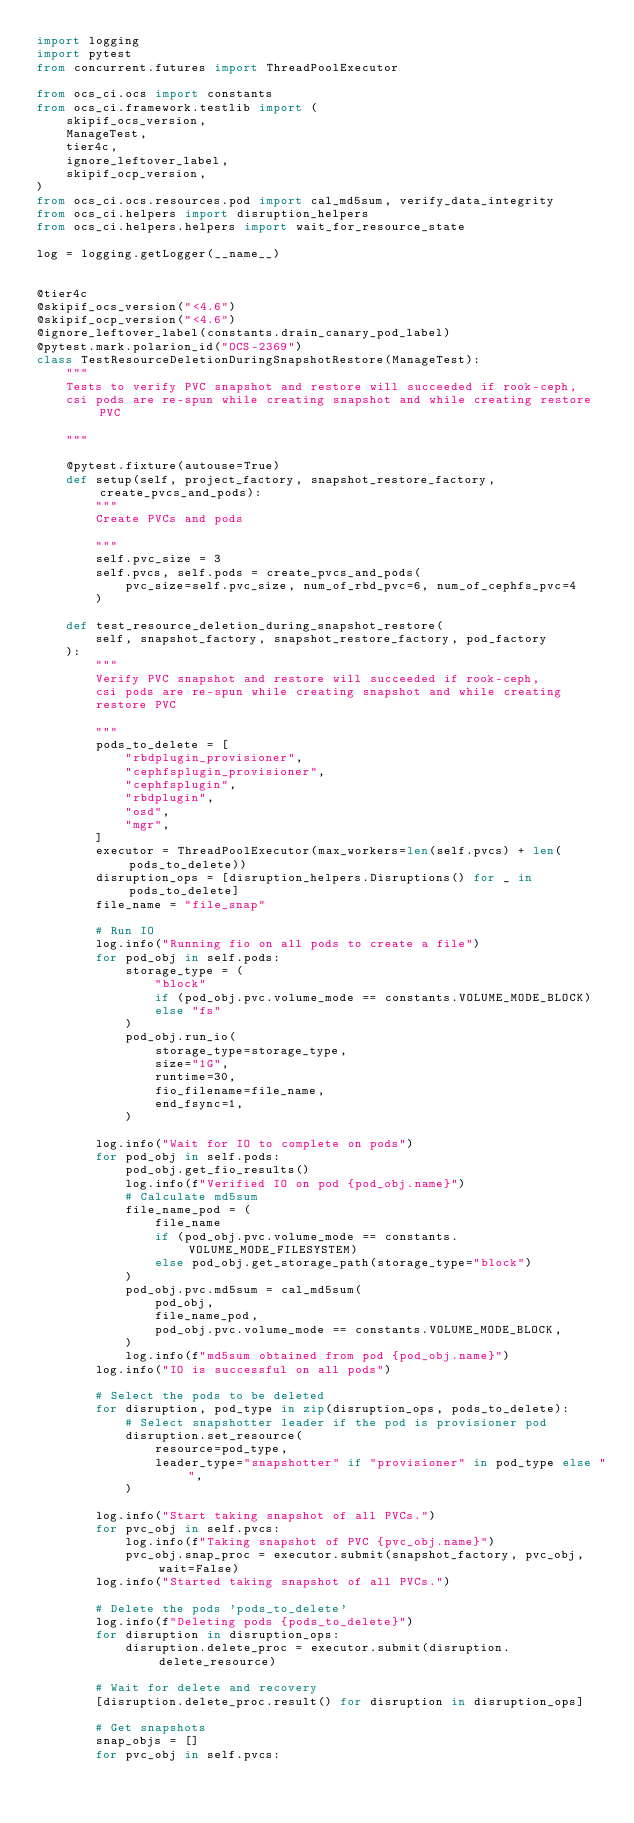Convert code to text. <code><loc_0><loc_0><loc_500><loc_500><_Python_>import logging
import pytest
from concurrent.futures import ThreadPoolExecutor

from ocs_ci.ocs import constants
from ocs_ci.framework.testlib import (
    skipif_ocs_version,
    ManageTest,
    tier4c,
    ignore_leftover_label,
    skipif_ocp_version,
)
from ocs_ci.ocs.resources.pod import cal_md5sum, verify_data_integrity
from ocs_ci.helpers import disruption_helpers
from ocs_ci.helpers.helpers import wait_for_resource_state

log = logging.getLogger(__name__)


@tier4c
@skipif_ocs_version("<4.6")
@skipif_ocp_version("<4.6")
@ignore_leftover_label(constants.drain_canary_pod_label)
@pytest.mark.polarion_id("OCS-2369")
class TestResourceDeletionDuringSnapshotRestore(ManageTest):
    """
    Tests to verify PVC snapshot and restore will succeeded if rook-ceph,
    csi pods are re-spun while creating snapshot and while creating restore PVC

    """

    @pytest.fixture(autouse=True)
    def setup(self, project_factory, snapshot_restore_factory, create_pvcs_and_pods):
        """
        Create PVCs and pods

        """
        self.pvc_size = 3
        self.pvcs, self.pods = create_pvcs_and_pods(
            pvc_size=self.pvc_size, num_of_rbd_pvc=6, num_of_cephfs_pvc=4
        )

    def test_resource_deletion_during_snapshot_restore(
        self, snapshot_factory, snapshot_restore_factory, pod_factory
    ):
        """
        Verify PVC snapshot and restore will succeeded if rook-ceph,
        csi pods are re-spun while creating snapshot and while creating
        restore PVC

        """
        pods_to_delete = [
            "rbdplugin_provisioner",
            "cephfsplugin_provisioner",
            "cephfsplugin",
            "rbdplugin",
            "osd",
            "mgr",
        ]
        executor = ThreadPoolExecutor(max_workers=len(self.pvcs) + len(pods_to_delete))
        disruption_ops = [disruption_helpers.Disruptions() for _ in pods_to_delete]
        file_name = "file_snap"

        # Run IO
        log.info("Running fio on all pods to create a file")
        for pod_obj in self.pods:
            storage_type = (
                "block"
                if (pod_obj.pvc.volume_mode == constants.VOLUME_MODE_BLOCK)
                else "fs"
            )
            pod_obj.run_io(
                storage_type=storage_type,
                size="1G",
                runtime=30,
                fio_filename=file_name,
                end_fsync=1,
            )

        log.info("Wait for IO to complete on pods")
        for pod_obj in self.pods:
            pod_obj.get_fio_results()
            log.info(f"Verified IO on pod {pod_obj.name}")
            # Calculate md5sum
            file_name_pod = (
                file_name
                if (pod_obj.pvc.volume_mode == constants.VOLUME_MODE_FILESYSTEM)
                else pod_obj.get_storage_path(storage_type="block")
            )
            pod_obj.pvc.md5sum = cal_md5sum(
                pod_obj,
                file_name_pod,
                pod_obj.pvc.volume_mode == constants.VOLUME_MODE_BLOCK,
            )
            log.info(f"md5sum obtained from pod {pod_obj.name}")
        log.info("IO is successful on all pods")

        # Select the pods to be deleted
        for disruption, pod_type in zip(disruption_ops, pods_to_delete):
            # Select snapshotter leader if the pod is provisioner pod
            disruption.set_resource(
                resource=pod_type,
                leader_type="snapshotter" if "provisioner" in pod_type else "",
            )

        log.info("Start taking snapshot of all PVCs.")
        for pvc_obj in self.pvcs:
            log.info(f"Taking snapshot of PVC {pvc_obj.name}")
            pvc_obj.snap_proc = executor.submit(snapshot_factory, pvc_obj, wait=False)
        log.info("Started taking snapshot of all PVCs.")

        # Delete the pods 'pods_to_delete'
        log.info(f"Deleting pods {pods_to_delete}")
        for disruption in disruption_ops:
            disruption.delete_proc = executor.submit(disruption.delete_resource)

        # Wait for delete and recovery
        [disruption.delete_proc.result() for disruption in disruption_ops]

        # Get snapshots
        snap_objs = []
        for pvc_obj in self.pvcs:</code> 